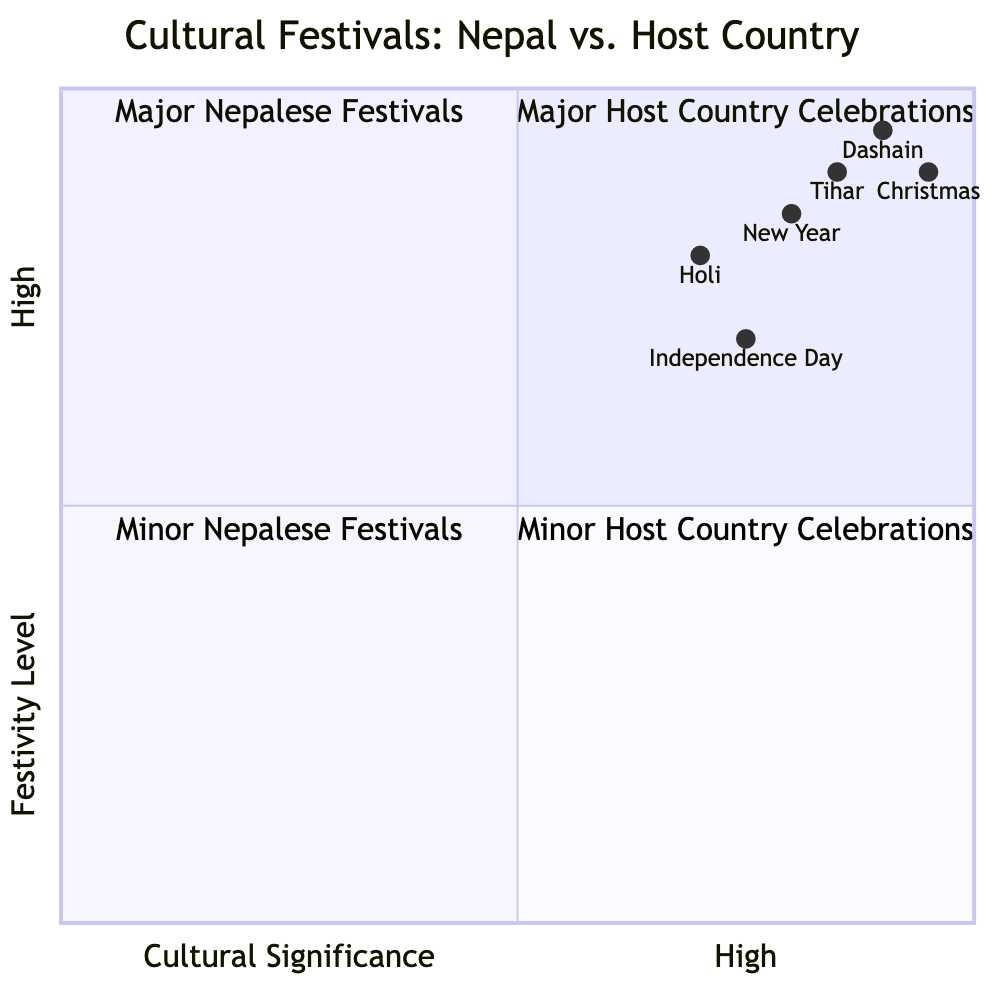What is the cultural significance score of Dashain? The diagram indicates that Dashain has a cultural significance score of 0.9, which is represented on the x-axis.
Answer: 0.9 Which festival has the highest festivity level? By examining the y-axis values of all festivals, Christmas has the highest festivity level at 0.9.
Answer: Christmas How many major host country celebrations are shown in the diagram? There are three major host country celebrations: Christmas, New Year, and Independence Day, as shown in quadrant 1.
Answer: 3 Which Nepalese festival is located in quadrant 2? The diagram shows that both Dashain and Tihar are categorized in quadrant 2, indicating they are major Nepalese festivals.
Answer: Dashain, Tihar What is the festivity level score of Independence Day? The diagram indicates that Independence Day has a festivity level score of 0.7, represented on the y-axis.
Answer: 0.7 Which festival has a lower cultural significance, Holi or New Year? Holi has a cultural significance score of 0.7, while New Year has a score of 0.8, making Holi the one with lower significance.
Answer: Holi How does the cultural significance of Tihar compare to Christmas? The cultural significance of Tihar is 0.85, while Christmas has a score of 0.95, indicating that Christmas has a higher cultural significance than Tihar.
Answer: Higher for Christmas Which quadrant contains the minor celebratory events? Quadrant 4 contains the minor host country celebrations, which are not highlighted in this diagram.
Answer: Quadrant 4 